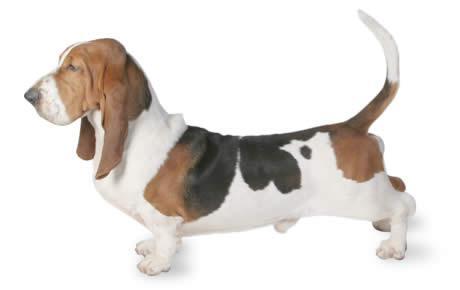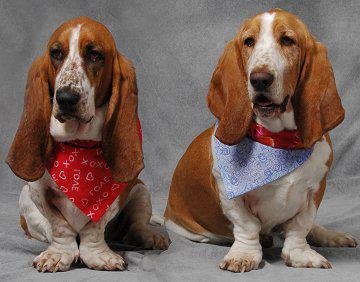The first image is the image on the left, the second image is the image on the right. Considering the images on both sides, is "Right and left images contain the same number of dogs." valid? Answer yes or no. No. The first image is the image on the left, the second image is the image on the right. For the images shown, is this caption "One of the images contains two or more basset hounds." true? Answer yes or no. Yes. 